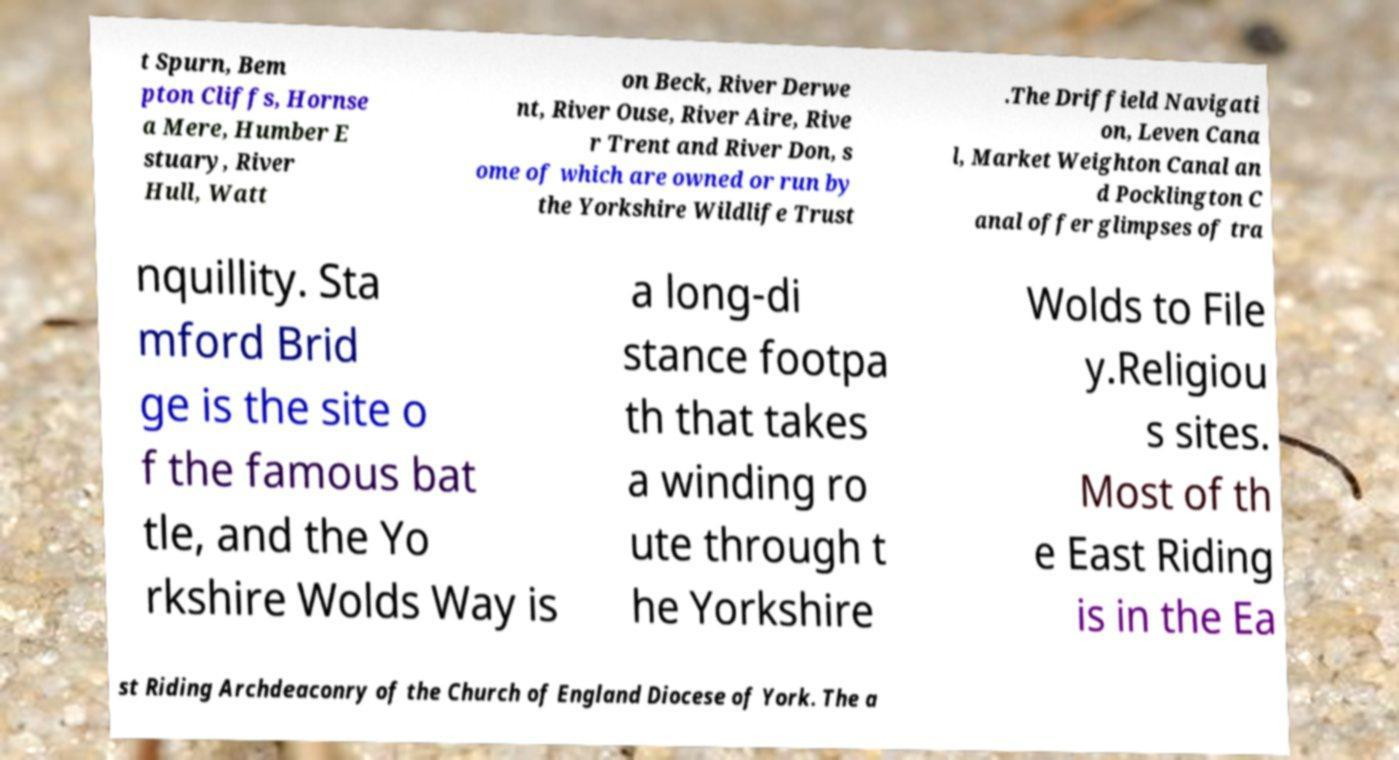Can you read and provide the text displayed in the image?This photo seems to have some interesting text. Can you extract and type it out for me? t Spurn, Bem pton Cliffs, Hornse a Mere, Humber E stuary, River Hull, Watt on Beck, River Derwe nt, River Ouse, River Aire, Rive r Trent and River Don, s ome of which are owned or run by the Yorkshire Wildlife Trust .The Driffield Navigati on, Leven Cana l, Market Weighton Canal an d Pocklington C anal offer glimpses of tra nquillity. Sta mford Brid ge is the site o f the famous bat tle, and the Yo rkshire Wolds Way is a long-di stance footpa th that takes a winding ro ute through t he Yorkshire Wolds to File y.Religiou s sites. Most of th e East Riding is in the Ea st Riding Archdeaconry of the Church of England Diocese of York. The a 